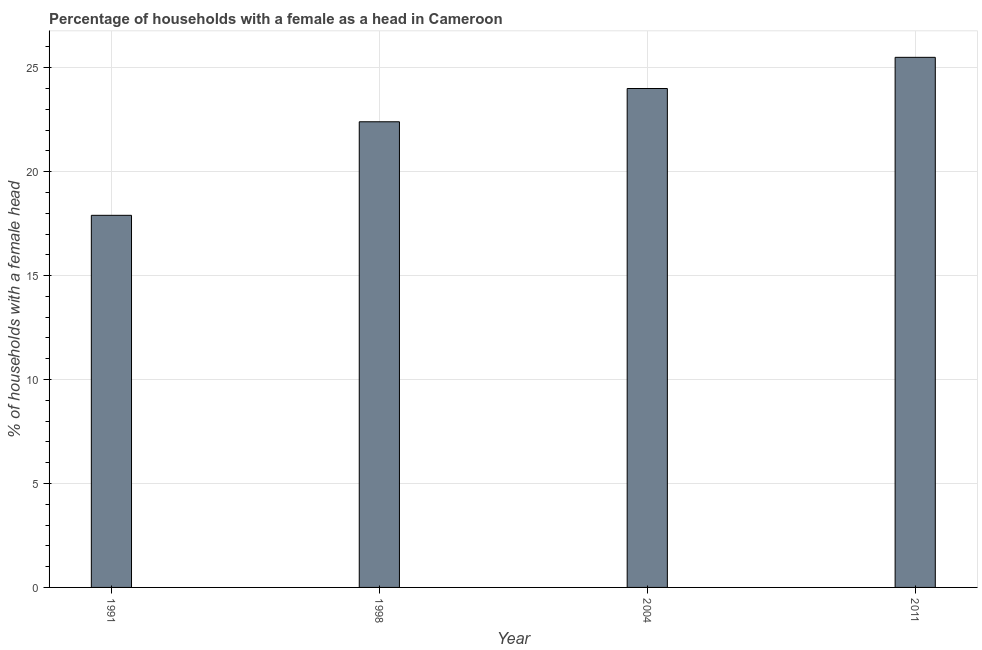Does the graph contain grids?
Give a very brief answer. Yes. What is the title of the graph?
Your answer should be very brief. Percentage of households with a female as a head in Cameroon. What is the label or title of the X-axis?
Provide a short and direct response. Year. What is the label or title of the Y-axis?
Offer a terse response. % of households with a female head. What is the number of female supervised households in 1998?
Make the answer very short. 22.4. In which year was the number of female supervised households maximum?
Offer a terse response. 2011. What is the sum of the number of female supervised households?
Provide a short and direct response. 89.8. What is the average number of female supervised households per year?
Offer a terse response. 22.45. What is the median number of female supervised households?
Make the answer very short. 23.2. Do a majority of the years between 1998 and 2011 (inclusive) have number of female supervised households greater than 20 %?
Make the answer very short. Yes. What is the ratio of the number of female supervised households in 2004 to that in 2011?
Your response must be concise. 0.94. Is the number of female supervised households in 1991 less than that in 2004?
Your answer should be compact. Yes. Is the sum of the number of female supervised households in 1991 and 1998 greater than the maximum number of female supervised households across all years?
Provide a short and direct response. Yes. How many years are there in the graph?
Your answer should be compact. 4. What is the difference between two consecutive major ticks on the Y-axis?
Your answer should be very brief. 5. What is the % of households with a female head in 1991?
Provide a succinct answer. 17.9. What is the % of households with a female head of 1998?
Ensure brevity in your answer.  22.4. What is the % of households with a female head of 2004?
Your response must be concise. 24. What is the difference between the % of households with a female head in 1991 and 2004?
Offer a very short reply. -6.1. What is the difference between the % of households with a female head in 1998 and 2004?
Make the answer very short. -1.6. What is the difference between the % of households with a female head in 2004 and 2011?
Keep it short and to the point. -1.5. What is the ratio of the % of households with a female head in 1991 to that in 1998?
Keep it short and to the point. 0.8. What is the ratio of the % of households with a female head in 1991 to that in 2004?
Give a very brief answer. 0.75. What is the ratio of the % of households with a female head in 1991 to that in 2011?
Provide a succinct answer. 0.7. What is the ratio of the % of households with a female head in 1998 to that in 2004?
Provide a short and direct response. 0.93. What is the ratio of the % of households with a female head in 1998 to that in 2011?
Give a very brief answer. 0.88. What is the ratio of the % of households with a female head in 2004 to that in 2011?
Your response must be concise. 0.94. 